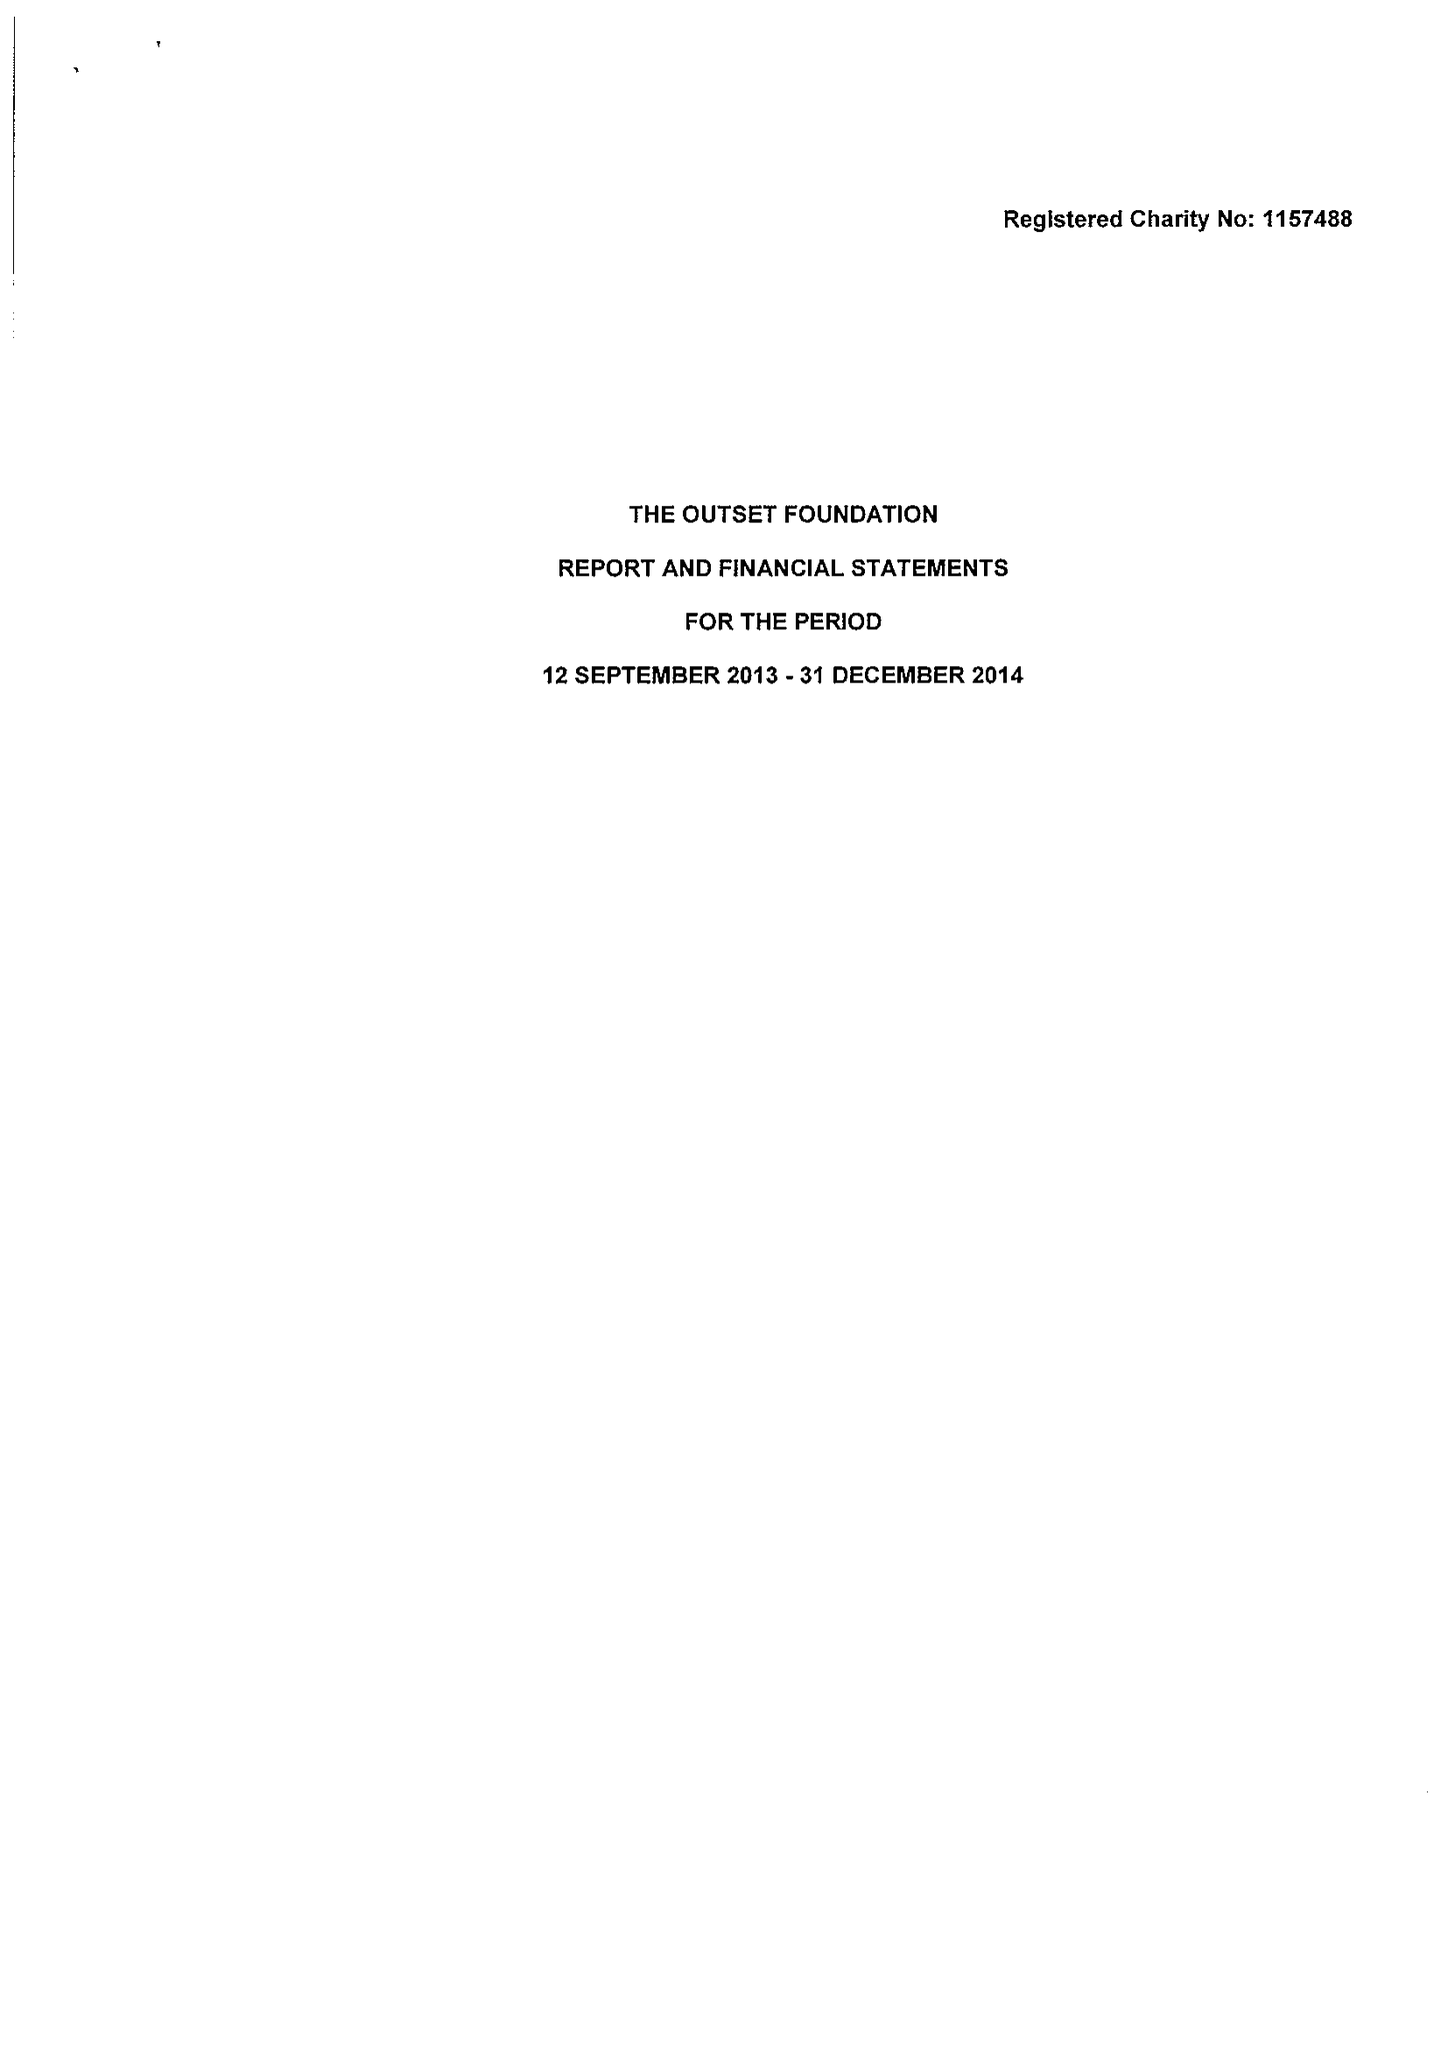What is the value for the address__postcode?
Answer the question using a single word or phrase. CB4 2QH 